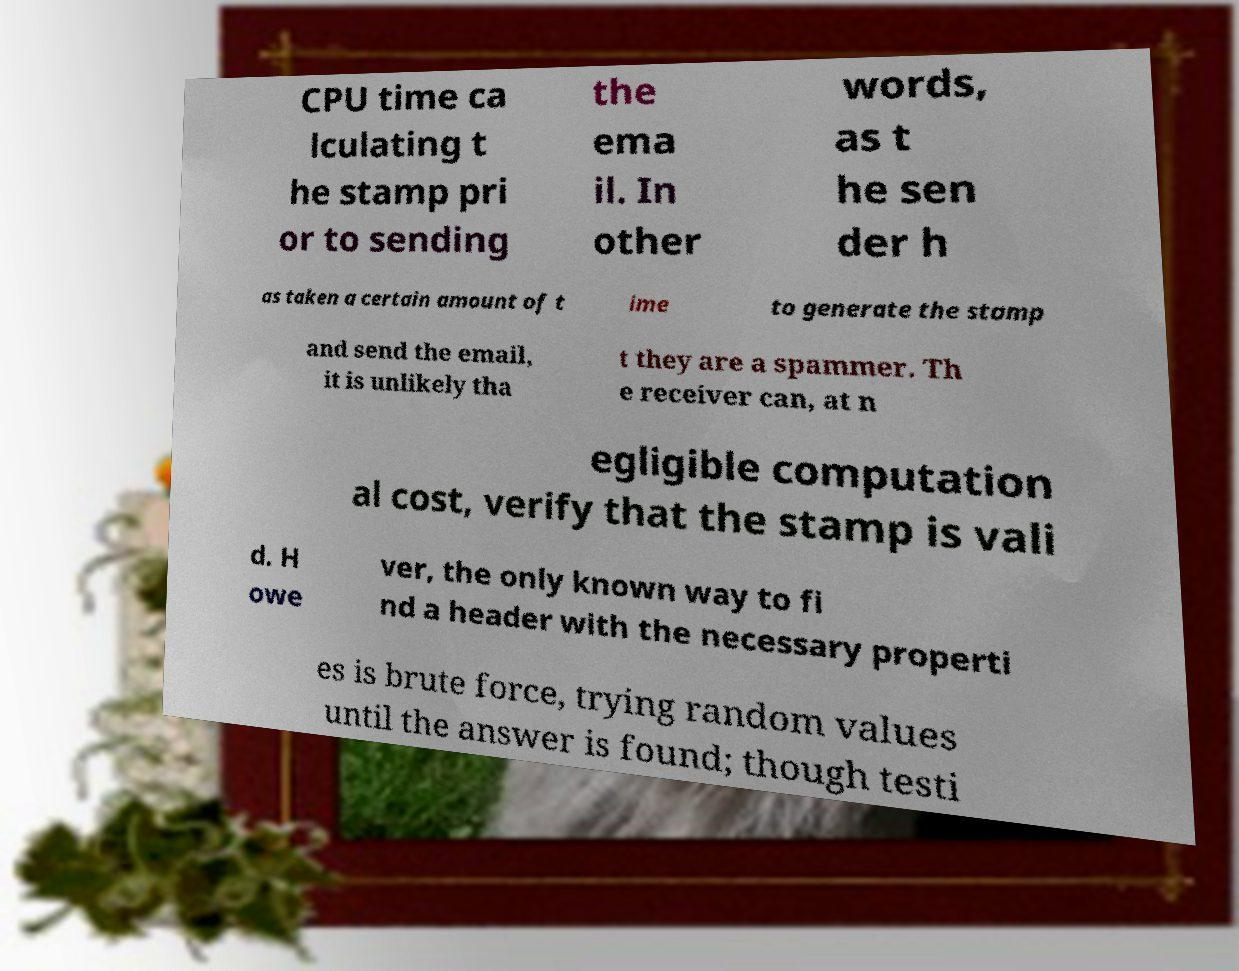There's text embedded in this image that I need extracted. Can you transcribe it verbatim? CPU time ca lculating t he stamp pri or to sending the ema il. In other words, as t he sen der h as taken a certain amount of t ime to generate the stamp and send the email, it is unlikely tha t they are a spammer. Th e receiver can, at n egligible computation al cost, verify that the stamp is vali d. H owe ver, the only known way to fi nd a header with the necessary properti es is brute force, trying random values until the answer is found; though testi 